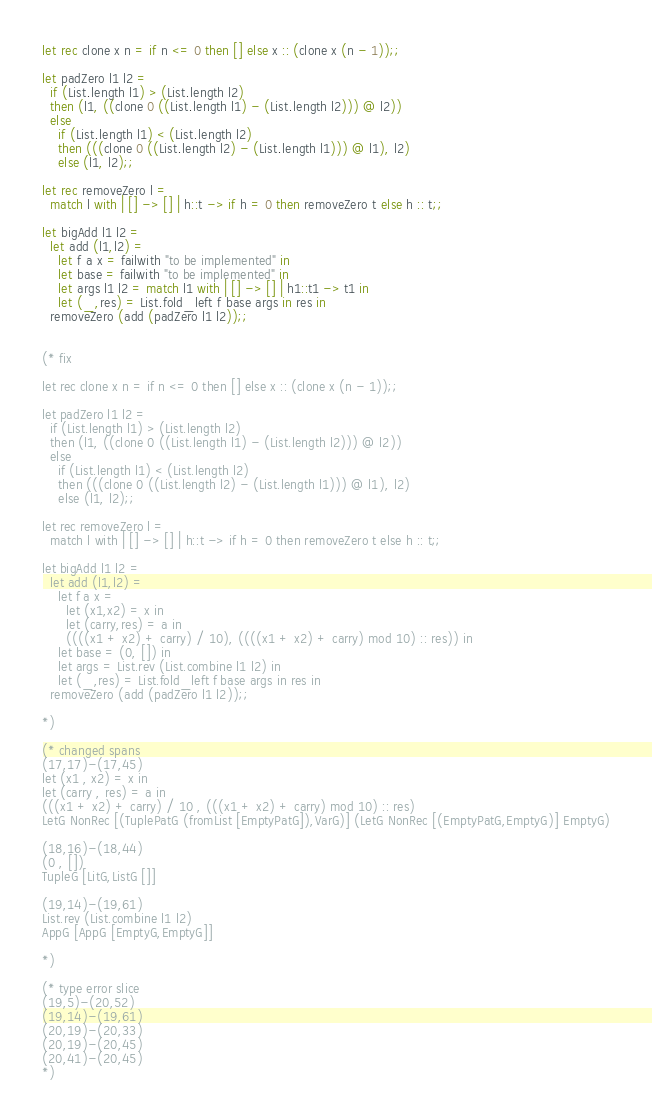Convert code to text. <code><loc_0><loc_0><loc_500><loc_500><_OCaml_>
let rec clone x n = if n <= 0 then [] else x :: (clone x (n - 1));;

let padZero l1 l2 =
  if (List.length l1) > (List.length l2)
  then (l1, ((clone 0 ((List.length l1) - (List.length l2))) @ l2))
  else
    if (List.length l1) < (List.length l2)
    then (((clone 0 ((List.length l2) - (List.length l1))) @ l1), l2)
    else (l1, l2);;

let rec removeZero l =
  match l with | [] -> [] | h::t -> if h = 0 then removeZero t else h :: t;;

let bigAdd l1 l2 =
  let add (l1,l2) =
    let f a x = failwith "to be implemented" in
    let base = failwith "to be implemented" in
    let args l1 l2 = match l1 with | [] -> [] | h1::t1 -> t1 in
    let (_,res) = List.fold_left f base args in res in
  removeZero (add (padZero l1 l2));;


(* fix

let rec clone x n = if n <= 0 then [] else x :: (clone x (n - 1));;

let padZero l1 l2 =
  if (List.length l1) > (List.length l2)
  then (l1, ((clone 0 ((List.length l1) - (List.length l2))) @ l2))
  else
    if (List.length l1) < (List.length l2)
    then (((clone 0 ((List.length l2) - (List.length l1))) @ l1), l2)
    else (l1, l2);;

let rec removeZero l =
  match l with | [] -> [] | h::t -> if h = 0 then removeZero t else h :: t;;

let bigAdd l1 l2 =
  let add (l1,l2) =
    let f a x =
      let (x1,x2) = x in
      let (carry,res) = a in
      ((((x1 + x2) + carry) / 10), ((((x1 + x2) + carry) mod 10) :: res)) in
    let base = (0, []) in
    let args = List.rev (List.combine l1 l2) in
    let (_,res) = List.fold_left f base args in res in
  removeZero (add (padZero l1 l2));;

*)

(* changed spans
(17,17)-(17,45)
let (x1 , x2) = x in
let (carry , res) = a in
(((x1 + x2) + carry) / 10 , (((x1 + x2) + carry) mod 10) :: res)
LetG NonRec [(TuplePatG (fromList [EmptyPatG]),VarG)] (LetG NonRec [(EmptyPatG,EmptyG)] EmptyG)

(18,16)-(18,44)
(0 , [])
TupleG [LitG,ListG []]

(19,14)-(19,61)
List.rev (List.combine l1 l2)
AppG [AppG [EmptyG,EmptyG]]

*)

(* type error slice
(19,5)-(20,52)
(19,14)-(19,61)
(20,19)-(20,33)
(20,19)-(20,45)
(20,41)-(20,45)
*)
</code> 